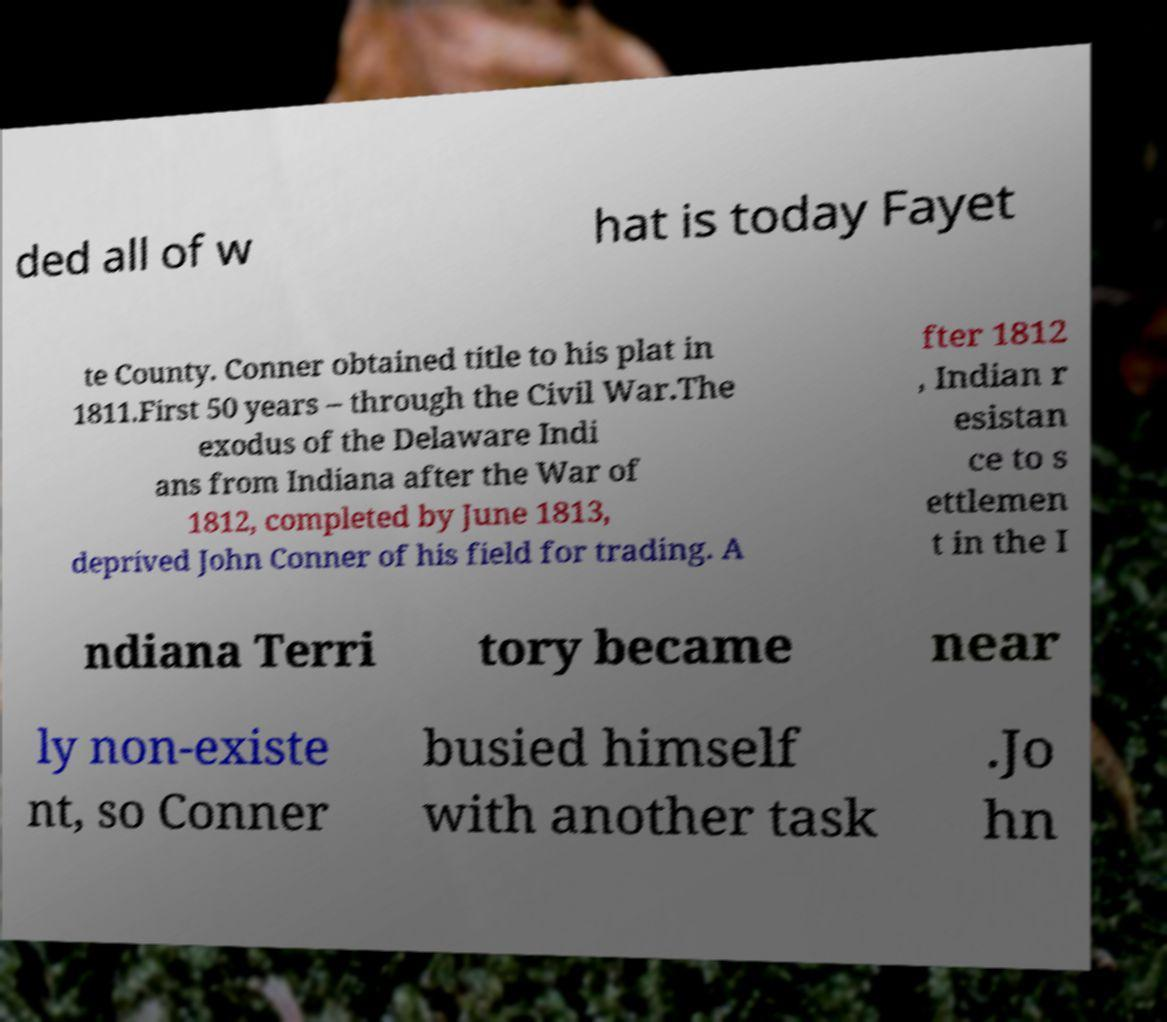Can you read and provide the text displayed in the image?This photo seems to have some interesting text. Can you extract and type it out for me? ded all of w hat is today Fayet te County. Conner obtained title to his plat in 1811.First 50 years – through the Civil War.The exodus of the Delaware Indi ans from Indiana after the War of 1812, completed by June 1813, deprived John Conner of his field for trading. A fter 1812 , Indian r esistan ce to s ettlemen t in the I ndiana Terri tory became near ly non-existe nt, so Conner busied himself with another task .Jo hn 